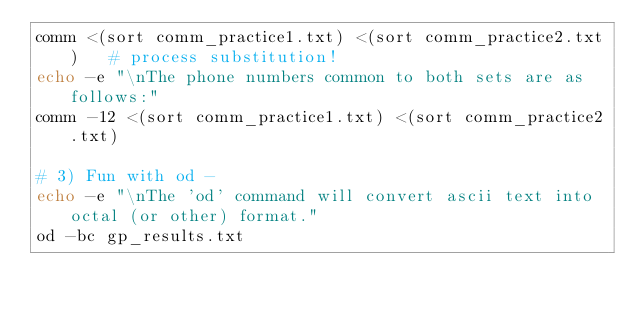<code> <loc_0><loc_0><loc_500><loc_500><_Bash_>comm <(sort comm_practice1.txt) <(sort comm_practice2.txt)   # process substitution!
echo -e "\nThe phone numbers common to both sets are as follows:"
comm -12 <(sort comm_practice1.txt) <(sort comm_practice2.txt)

# 3) Fun with od - 
echo -e "\nThe 'od' command will convert ascii text into octal (or other) format."
od -bc gp_results.txt
</code> 